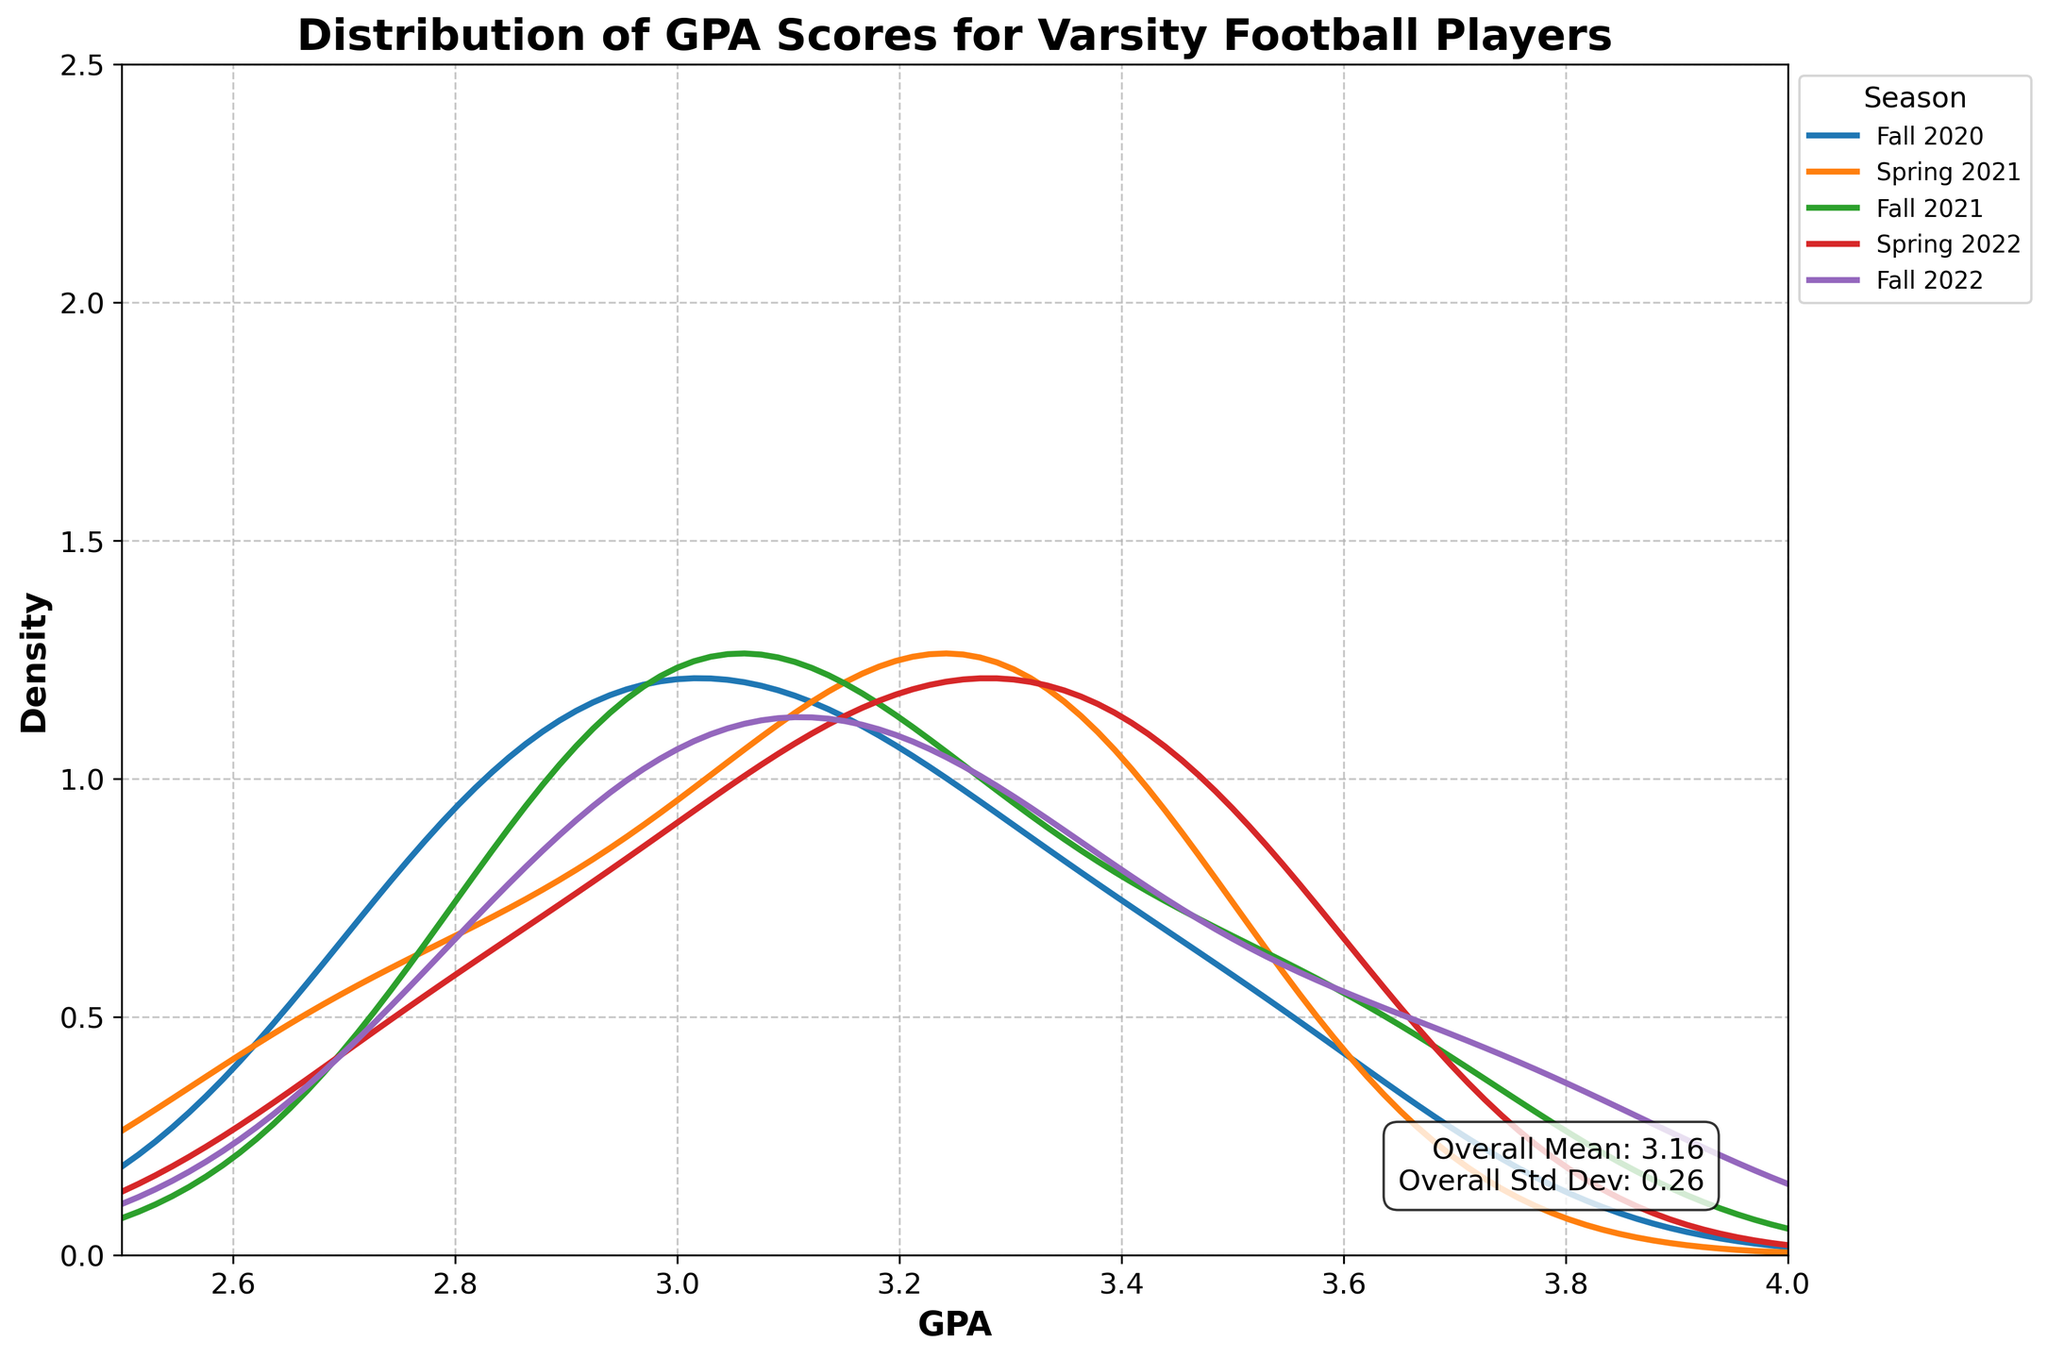What is the title of the plot? The title is the text displayed prominently at the top of the plot, summarizing what the plot represents.
Answer: Distribution of GPA Scores for Varsity Football Players What is the overall mean GPA? The overall mean GPA is given in the text box on the plot.
Answer: 3.14 Which season shows the widest spread of GPA scores? The season with the widest spread will have the broadest distribution curve in the plot.
Answer: Fall 2020 What is the peak density value for Fall 2021? The peak density value is the highest point on the distribution curve for Fall 2021.
Answer: Approximately 1.8 Do any seasons have a higher density around a GPA of 3.5? Look at the curves and see which, if any, have a peak or significant value around a GPA of 3.5.
Answer: Yes, Fall 2021 and Spring 2022 Which season has the highest overall GPA density? The season with the highest peak on its distribution curve has the highest overall density.
Answer: Fall 2021 Compare the density of GPA scores between Fall 2020 and Spring 2021 around the GPA of 2.9. Which one is higher? By examining the distribution curves, compare the y-values (density) at GPA 2.9 for Fall 2020 and Spring 2021.
Answer: Fall 2020 What is the density of GPA scores in Fall 2022 around GPA 3.0? Look at the Fall 2022 curve and note the density value at a GPA of 3.0.
Answer: Approximately 1.3 Which season has the narrowest distribution of GPA scores? The narrowest distribution will be the season with the sharpest peak and least spread out curve.
Answer: Fall 2022 